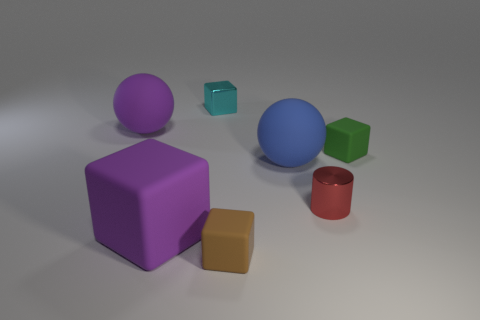Subtract 1 cubes. How many cubes are left? 3 Subtract all green blocks. Subtract all purple cylinders. How many blocks are left? 3 Add 2 small red cylinders. How many objects exist? 9 Subtract all blocks. How many objects are left? 3 Add 7 green blocks. How many green blocks are left? 8 Add 3 small shiny cubes. How many small shiny cubes exist? 4 Subtract 0 yellow spheres. How many objects are left? 7 Subtract all cyan shiny objects. Subtract all big purple metallic balls. How many objects are left? 6 